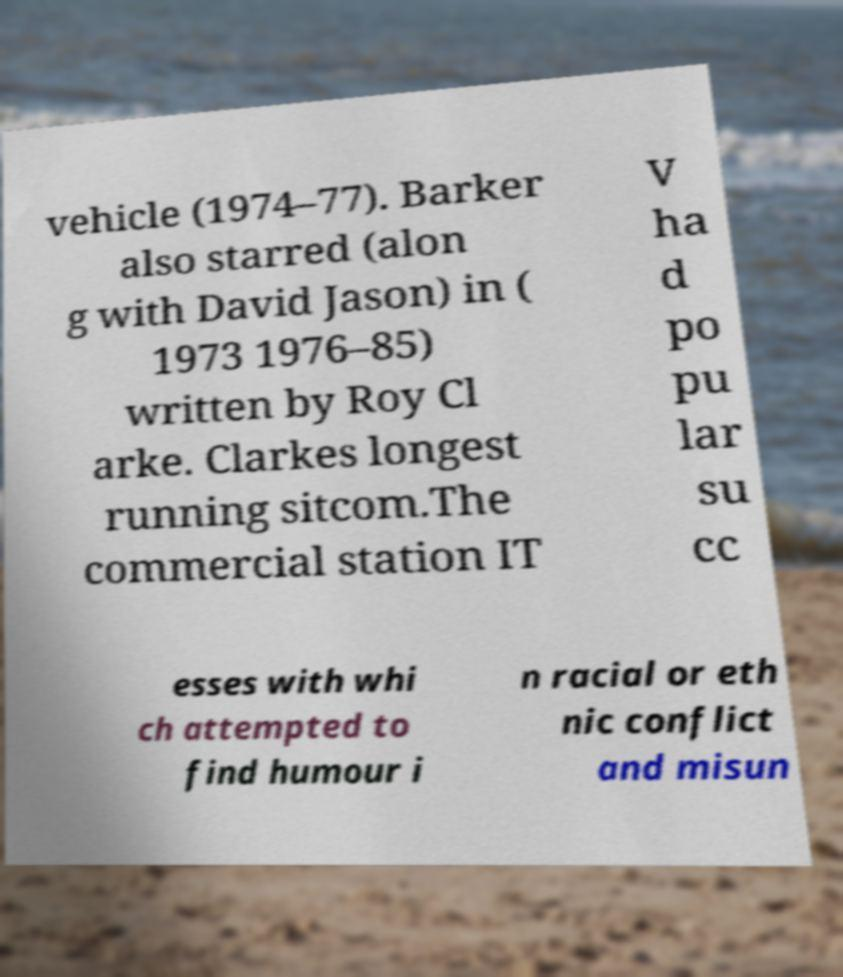Could you assist in decoding the text presented in this image and type it out clearly? vehicle (1974–77). Barker also starred (alon g with David Jason) in ( 1973 1976–85) written by Roy Cl arke. Clarkes longest running sitcom.The commercial station IT V ha d po pu lar su cc esses with whi ch attempted to find humour i n racial or eth nic conflict and misun 